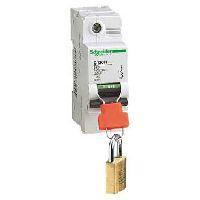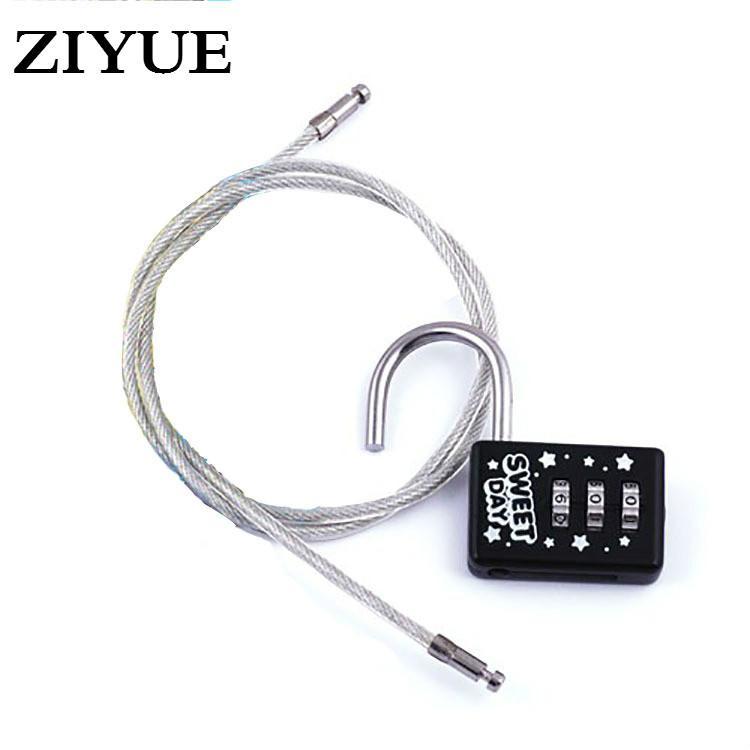The first image is the image on the left, the second image is the image on the right. For the images displayed, is the sentence "The left image shows a lock with a key on a keychain inserted." factually correct? Answer yes or no. No. 